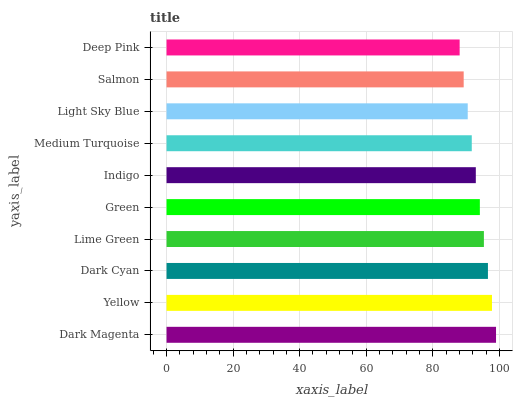Is Deep Pink the minimum?
Answer yes or no. Yes. Is Dark Magenta the maximum?
Answer yes or no. Yes. Is Yellow the minimum?
Answer yes or no. No. Is Yellow the maximum?
Answer yes or no. No. Is Dark Magenta greater than Yellow?
Answer yes or no. Yes. Is Yellow less than Dark Magenta?
Answer yes or no. Yes. Is Yellow greater than Dark Magenta?
Answer yes or no. No. Is Dark Magenta less than Yellow?
Answer yes or no. No. Is Green the high median?
Answer yes or no. Yes. Is Indigo the low median?
Answer yes or no. Yes. Is Medium Turquoise the high median?
Answer yes or no. No. Is Lime Green the low median?
Answer yes or no. No. 